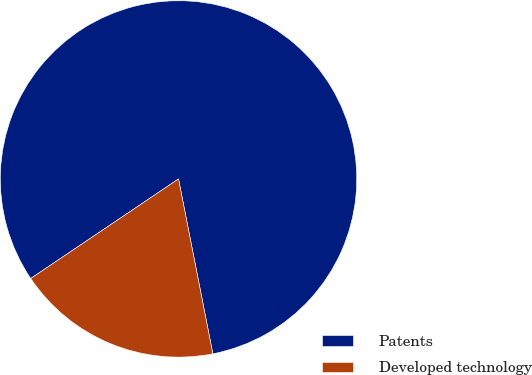Convert chart. <chart><loc_0><loc_0><loc_500><loc_500><pie_chart><fcel>Patents<fcel>Developed technology<nl><fcel>81.35%<fcel>18.65%<nl></chart> 